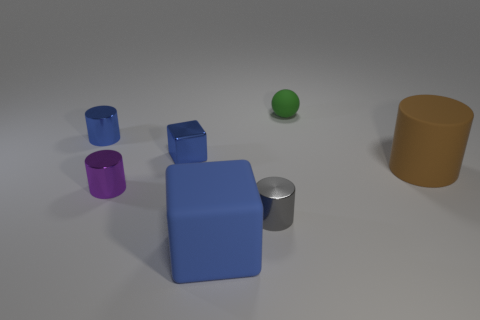How many blue metallic objects have the same shape as the purple object?
Make the answer very short. 1. How many red metal spheres are there?
Provide a short and direct response. 0. The big thing that is on the left side of the large brown rubber thing is what color?
Provide a short and direct response. Blue. There is a large object that is behind the blue object in front of the brown cylinder; what is its color?
Your answer should be compact. Brown. The sphere that is the same size as the shiny block is what color?
Keep it short and to the point. Green. What number of matte things are both in front of the small blue cylinder and to the right of the gray cylinder?
Your answer should be very brief. 1. There is a big matte object that is the same color as the small metal block; what shape is it?
Keep it short and to the point. Cube. There is a cylinder that is both on the left side of the big brown rubber cylinder and right of the big blue cube; what material is it?
Ensure brevity in your answer.  Metal. Are there fewer green rubber objects that are in front of the green sphere than gray cylinders behind the small blue cylinder?
Make the answer very short. No. What is the size of the green sphere that is made of the same material as the large cube?
Ensure brevity in your answer.  Small. 